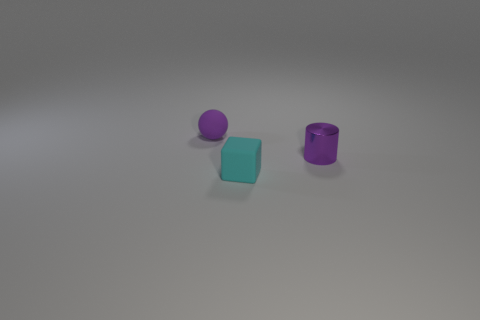There is a thing that is the same color as the small ball; what material is it?
Your answer should be compact. Metal. What number of other tiny purple shiny objects have the same shape as the tiny purple shiny thing?
Your response must be concise. 0. There is a thing that is to the left of the cyan object; is its color the same as the small thing that is right of the tiny cyan block?
Provide a succinct answer. Yes. There is a purple cylinder that is the same size as the cyan matte block; what is its material?
Your response must be concise. Metal. Are there any green metallic things that have the same size as the purple matte ball?
Provide a short and direct response. No. Are there fewer small cubes that are behind the purple rubber thing than cyan matte objects?
Provide a short and direct response. Yes. Is the number of tiny purple rubber objects on the right side of the small purple matte sphere less than the number of small purple things that are behind the tiny purple cylinder?
Ensure brevity in your answer.  Yes. How many cylinders are purple rubber objects or purple metallic objects?
Keep it short and to the point. 1. Are the tiny thing left of the cyan cube and the purple object on the right side of the tiny purple rubber sphere made of the same material?
Your answer should be very brief. No. There is a shiny thing that is the same size as the rubber block; what is its shape?
Provide a short and direct response. Cylinder. 